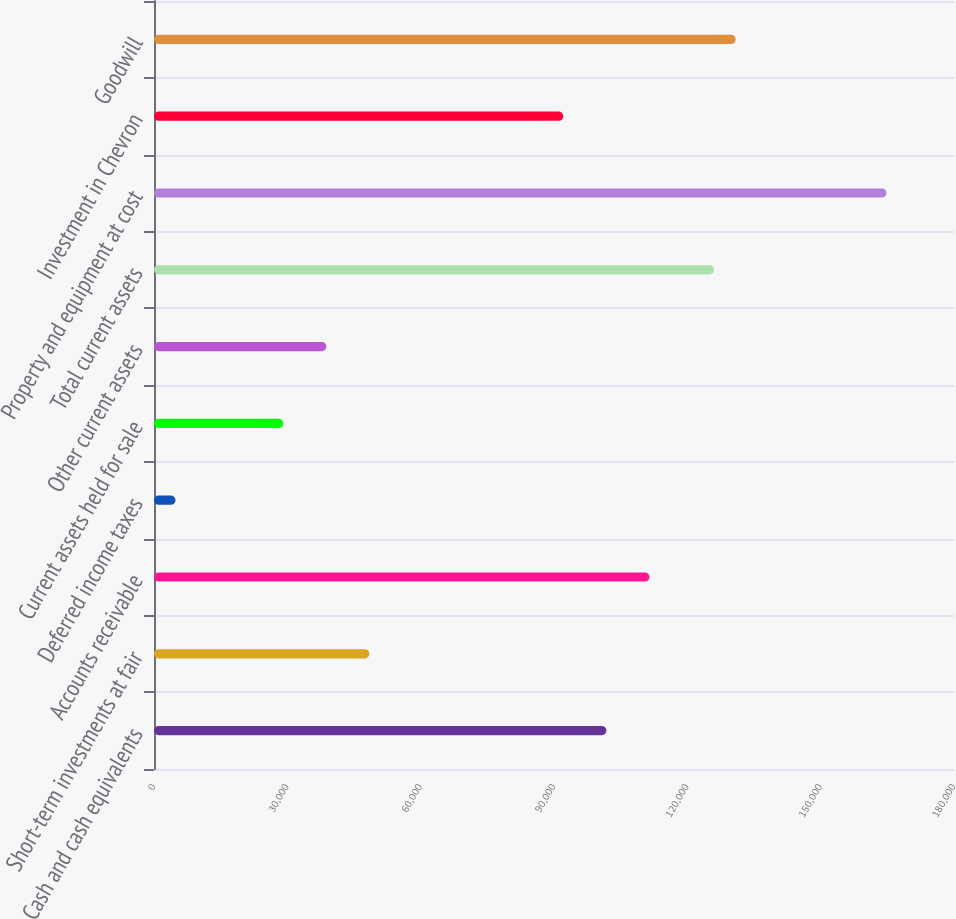Convert chart. <chart><loc_0><loc_0><loc_500><loc_500><bar_chart><fcel>Cash and cash equivalents<fcel>Short-term investments at fair<fcel>Accounts receivable<fcel>Deferred income taxes<fcel>Current assets held for sale<fcel>Other current assets<fcel>Total current assets<fcel>Property and equipment at cost<fcel>Investment in Chevron<fcel>Goodwill<nl><fcel>101792<fcel>48473<fcel>111487<fcel>4848.2<fcel>29084.2<fcel>38778.6<fcel>126028<fcel>164806<fcel>92097.8<fcel>130875<nl></chart> 